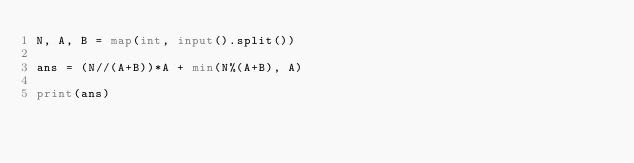Convert code to text. <code><loc_0><loc_0><loc_500><loc_500><_Python_>N, A, B = map(int, input().split())

ans = (N//(A+B))*A + min(N%(A+B), A)

print(ans)</code> 